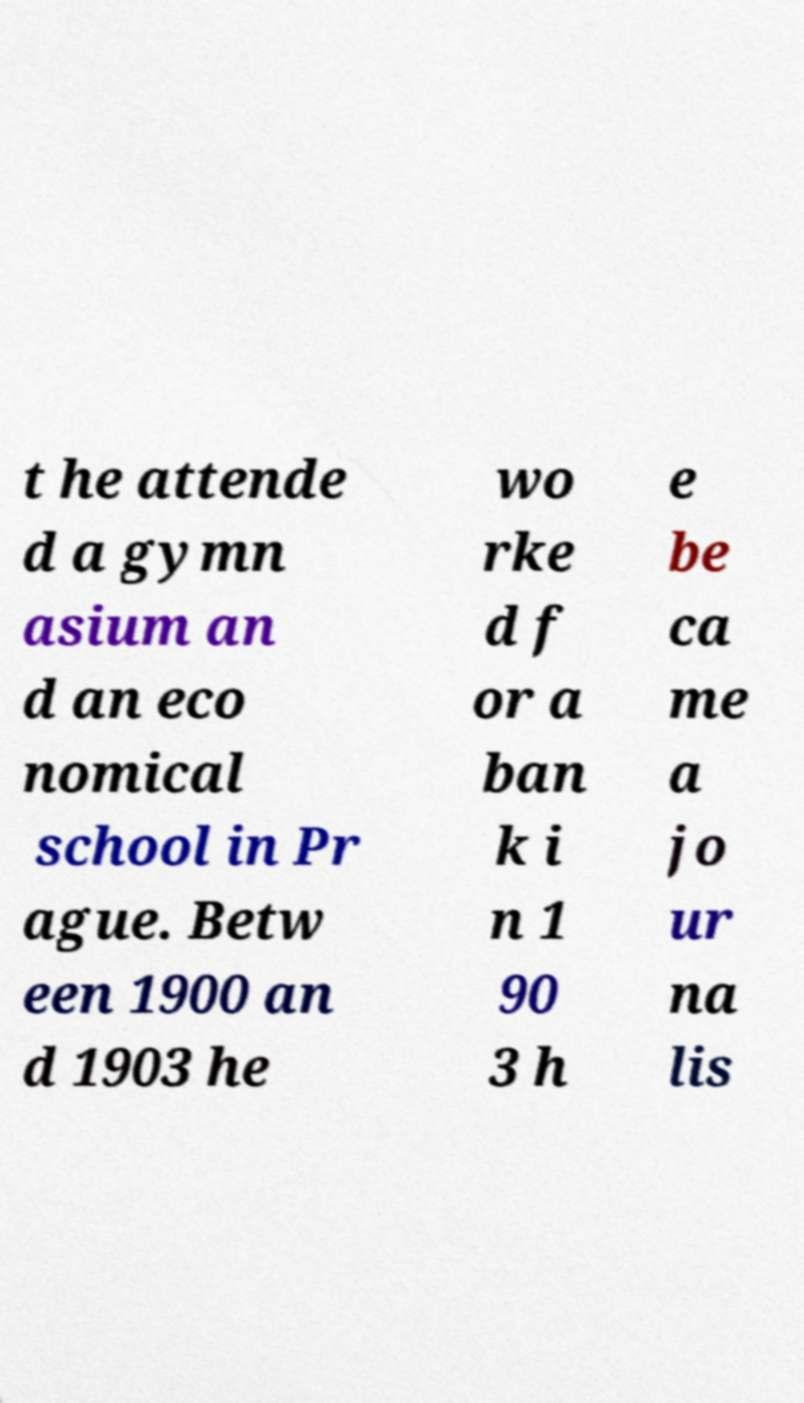Please identify and transcribe the text found in this image. t he attende d a gymn asium an d an eco nomical school in Pr ague. Betw een 1900 an d 1903 he wo rke d f or a ban k i n 1 90 3 h e be ca me a jo ur na lis 